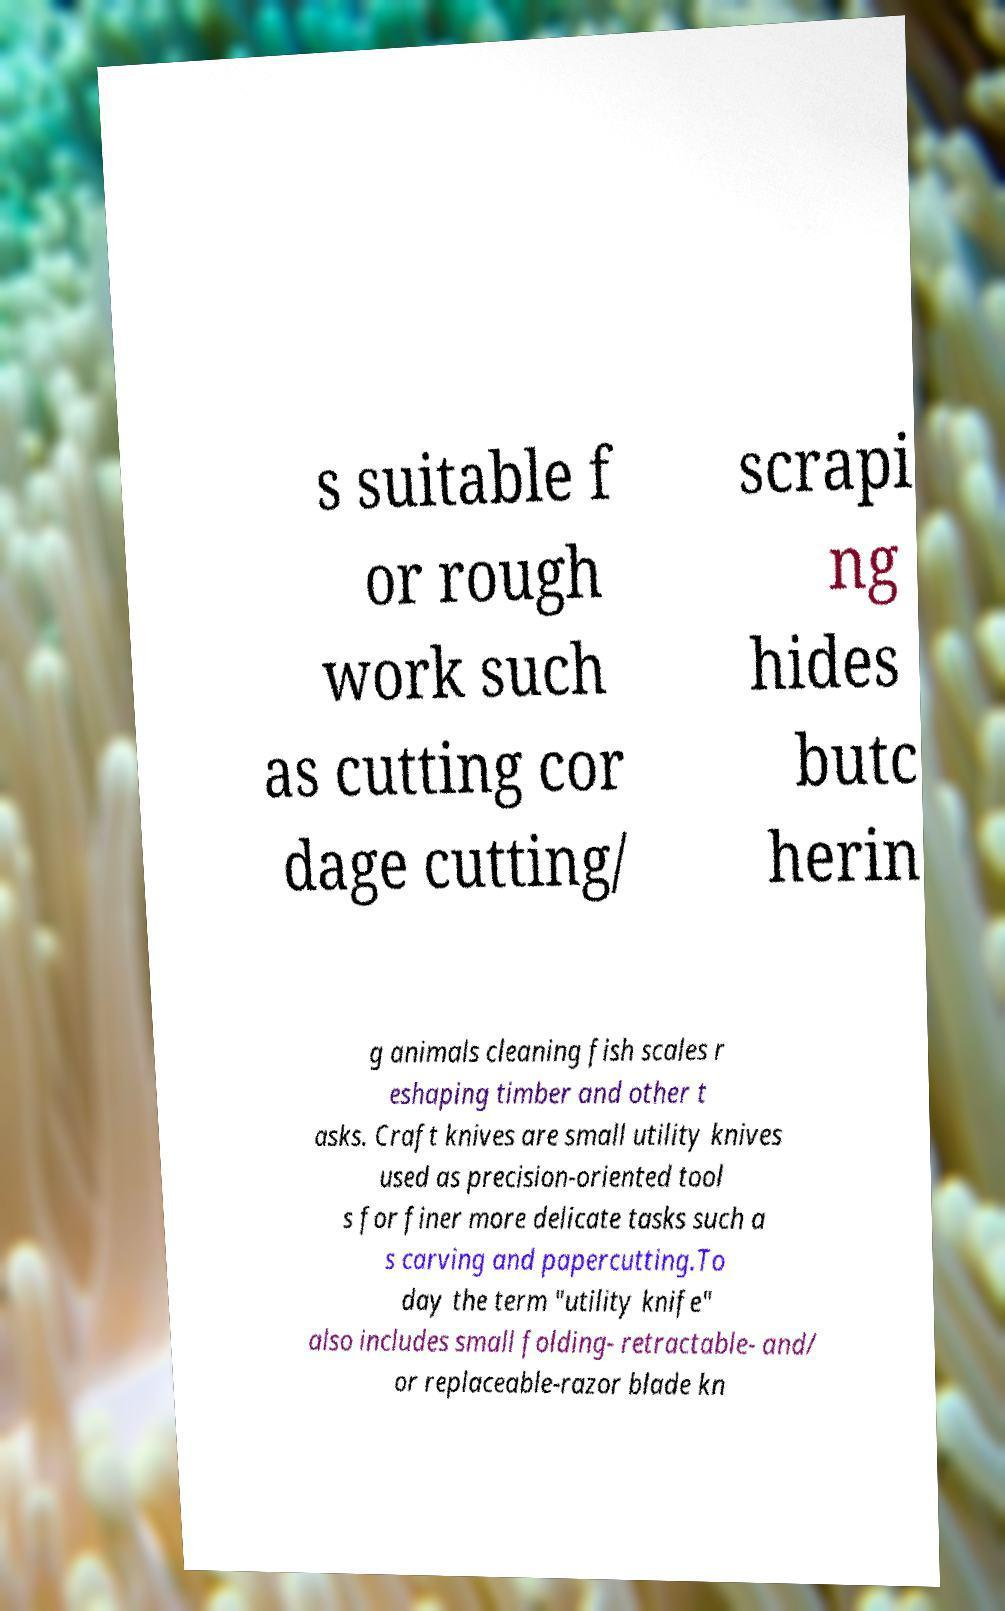For documentation purposes, I need the text within this image transcribed. Could you provide that? s suitable f or rough work such as cutting cor dage cutting/ scrapi ng hides butc herin g animals cleaning fish scales r eshaping timber and other t asks. Craft knives are small utility knives used as precision-oriented tool s for finer more delicate tasks such a s carving and papercutting.To day the term "utility knife" also includes small folding- retractable- and/ or replaceable-razor blade kn 